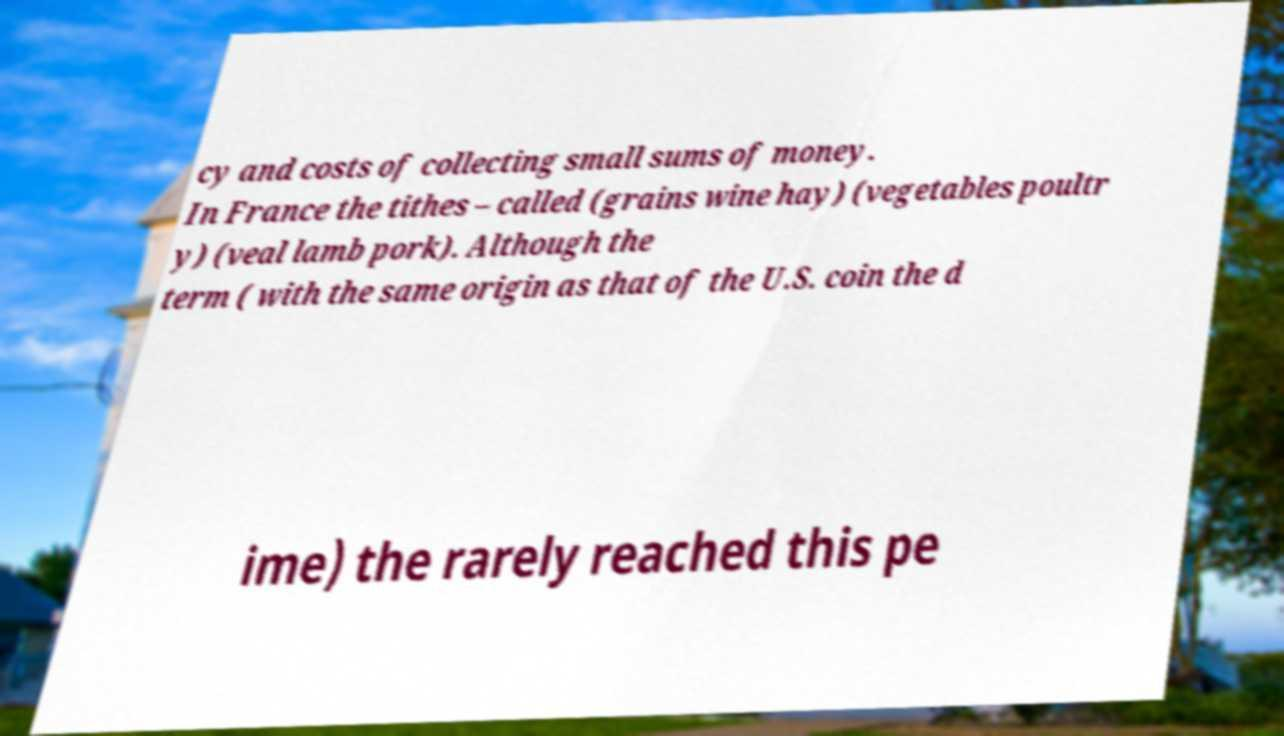I need the written content from this picture converted into text. Can you do that? cy and costs of collecting small sums of money. In France the tithes – called (grains wine hay) (vegetables poultr y) (veal lamb pork). Although the term ( with the same origin as that of the U.S. coin the d ime) the rarely reached this pe 